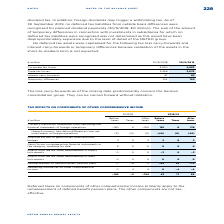According to Metro Ag's financial document, Why were no deferred tax assets capitalised for the following tax loss carry-forwards and interest carry-forwards or temporary differences? because realisation of the assets in the short-to-medium term is not expected. The document states: "interest carry-forwards or temporary differences because realisation of the assets in the short-to-medium term is not expected:..." Also, What do the loss carry-forwards as of the closing date predominantly concern? the German consolidation group. They can be carried forward without limitation.. The document states: "wards as of the closing date predominantly concern the German consolidation group. They can be carried forward without limitation. TAX EFFECTS ON COMP..." Also, What are the components in the table whereby no deferred tax assets were capitalised? The document contains multiple relevant values: Corporate tax losses, Trade tax losses, Interest carry-forwards, Temporary differences. From the document: "Interest carry-forwards 57 83 Temporary differences 104 120 Trade tax losses 3,296 3,679 Corporate tax losses 4,320 4,883..." Additionally, In which year were the temporary differences larger? According to the financial document, 2019. The relevant text states: "€ million 30/9/2018 30/9/2019..." Also, can you calculate: What was the change in interest carry-forwards in FY2019 from FY2018? Based on the calculation: 83-57, the result is 26 (in millions). This is based on the information: "Interest carry-forwards 57 83 Interest carry-forwards 57 83..." The key data points involved are: 57, 83. Also, can you calculate: What was the percentage change in interest carry-forwards in FY2019 from FY2018? To answer this question, I need to perform calculations using the financial data. The calculation is: (83-57)/57, which equals 45.61 (percentage). This is based on the information: "Interest carry-forwards 57 83 Interest carry-forwards 57 83..." The key data points involved are: 57, 83. 